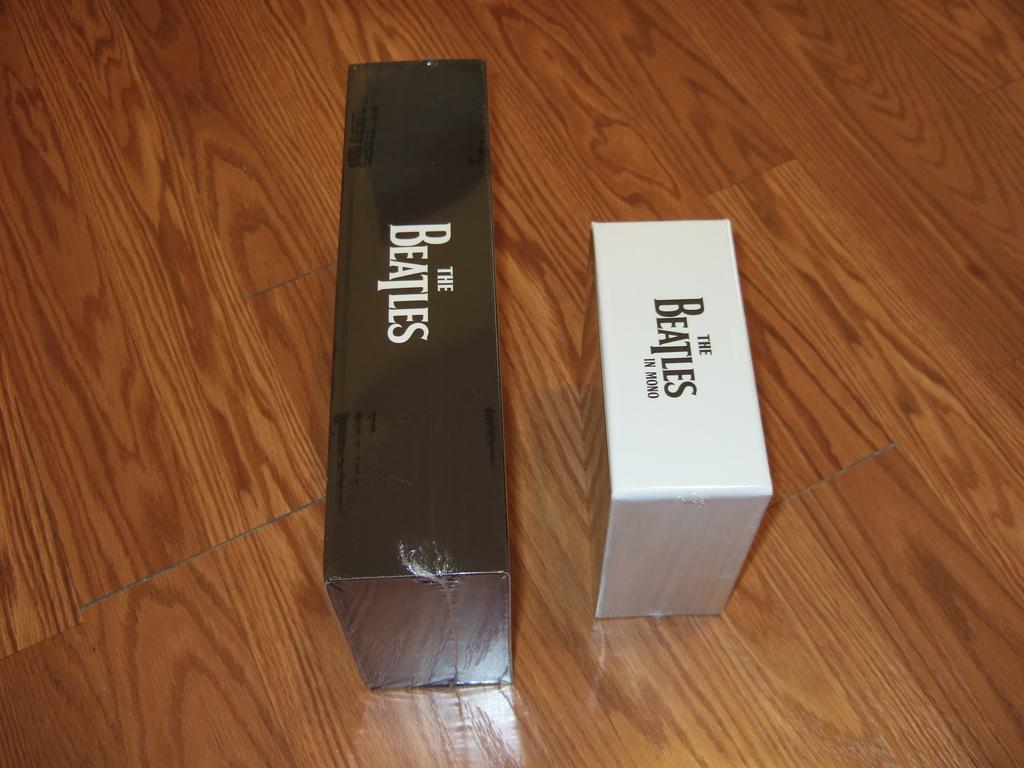<image>
Create a compact narrative representing the image presented. Two boxes that say The Beatles are sitting on a wooden table. 